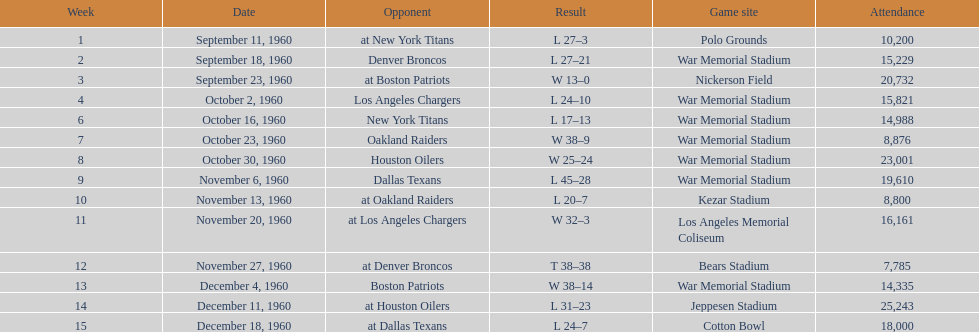How many games had at least 10,000 people in attendance? 11. 